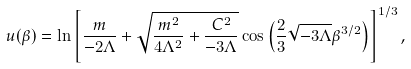Convert formula to latex. <formula><loc_0><loc_0><loc_500><loc_500>u ( \beta ) = \ln \left [ \frac { m } { - 2 \Lambda } + \sqrt { \frac { m ^ { 2 } } { 4 \Lambda ^ { 2 } } + \frac { C ^ { 2 } } { - 3 \Lambda } } \cos \left ( \frac { 2 } { 3 } \sqrt { - 3 \Lambda } \beta ^ { 3 / 2 } \right ) \right ] ^ { 1 / 3 } ,</formula> 